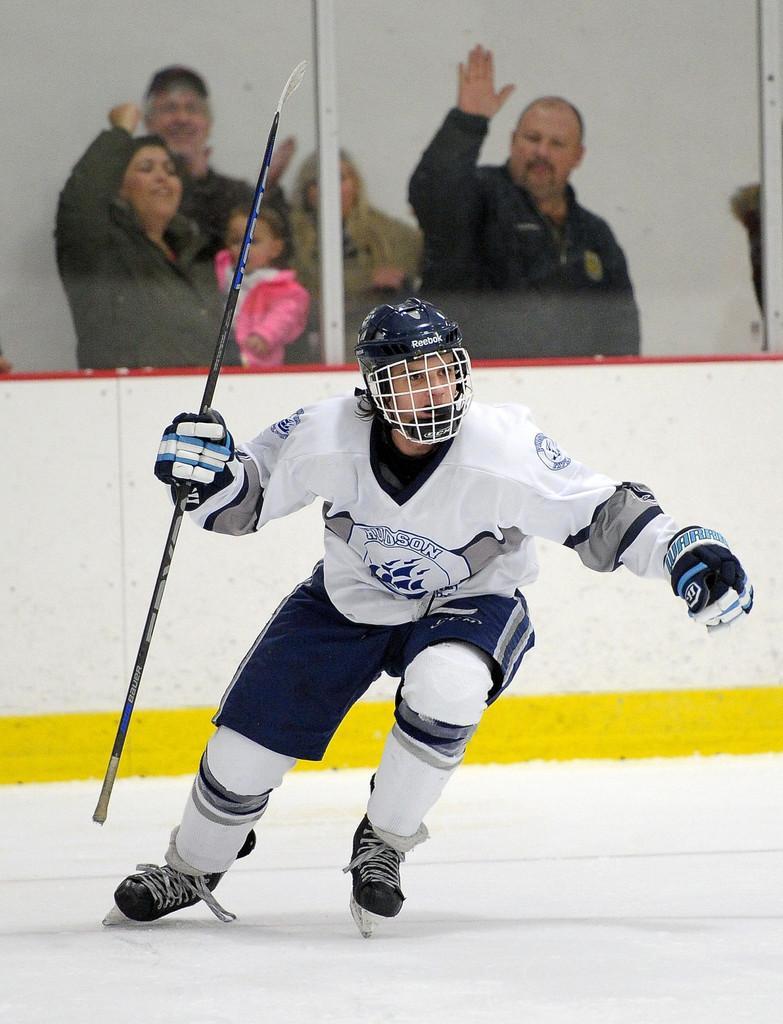Could you give a brief overview of what you see in this image? In this picture I can see there is a person skating on the ice and he is holding a stick and in the backdrop I can see there are few people standing. 